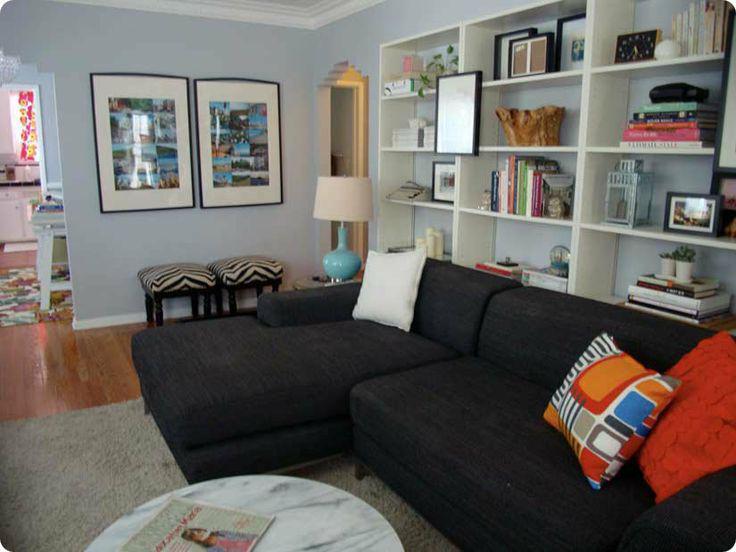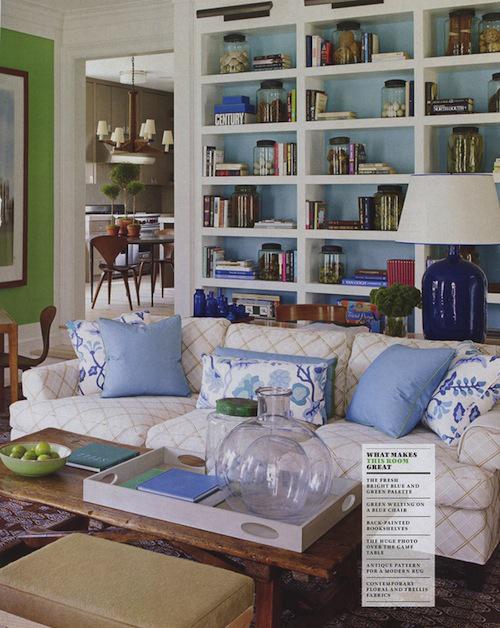The first image is the image on the left, the second image is the image on the right. Examine the images to the left and right. Is the description "In each image, a standard sized sofa with extra throw pillows and a coffee table in front of it sits parallel to a wall shelving unit." accurate? Answer yes or no. No. The first image is the image on the left, the second image is the image on the right. Given the left and right images, does the statement "An image shows a dark sectional couch with a white pillow on one end and patterned and orange pillows on the other end." hold true? Answer yes or no. Yes. 